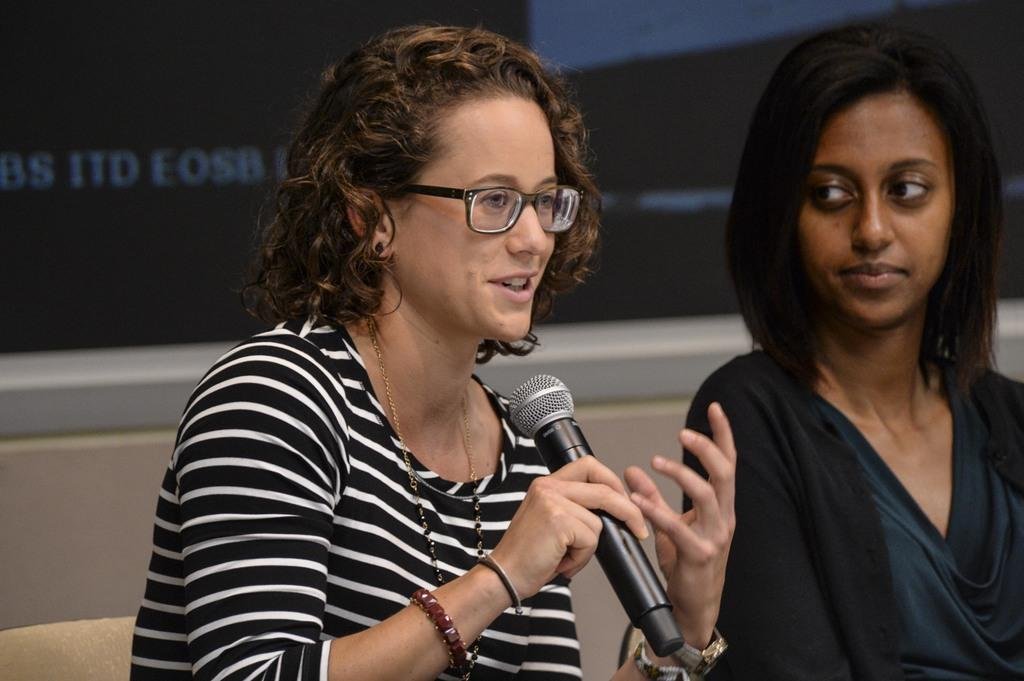How many people are in the image? There are two people in the image. What can be observed about the clothing of the people in the image? The people are wearing different color dresses. What accessory is one of the people wearing? One person is wearing glasses. What is the person with glasses holding? The person with glasses is holding a microphone. What can be seen in the background of the image? There is a screen visible in the background of the image. Can you tell me how the donkey is tied to the screen in the image? There is no donkey present in the image, so it is not possible to answer that question. 